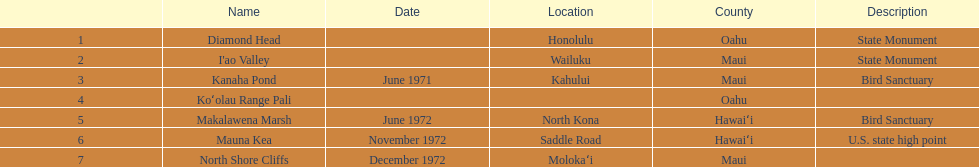What are the diverse milestone names? Diamond Head, I'ao Valley, Kanaha Pond, Koʻolau Range Pali, Makalawena Marsh, Mauna Kea, North Shore Cliffs. Which of these is positioned in the county hawai`i? Makalawena Marsh, Mauna Kea. Could you parse the entire table? {'header': ['', 'Name', 'Date', 'Location', 'County', 'Description'], 'rows': [['1', 'Diamond Head', '', 'Honolulu', 'Oahu', 'State Monument'], ['2', "I'ao Valley", '', 'Wailuku', 'Maui', 'State Monument'], ['3', 'Kanaha Pond', 'June 1971', 'Kahului', 'Maui', 'Bird Sanctuary'], ['4', 'Koʻolau Range Pali', '', '', 'Oahu', ''], ['5', 'Makalawena Marsh', 'June 1972', 'North Kona', 'Hawaiʻi', 'Bird Sanctuary'], ['6', 'Mauna Kea', 'November 1972', 'Saddle Road', 'Hawaiʻi', 'U.S. state high point'], ['7', 'North Shore Cliffs', 'December 1972', 'Molokaʻi', 'Maui', '']]} Which of these is not mauna kea? Makalawena Marsh. 